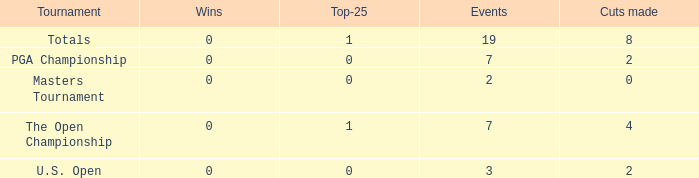What is the total number of cuts made of tournaments with 2 Events? 1.0. 